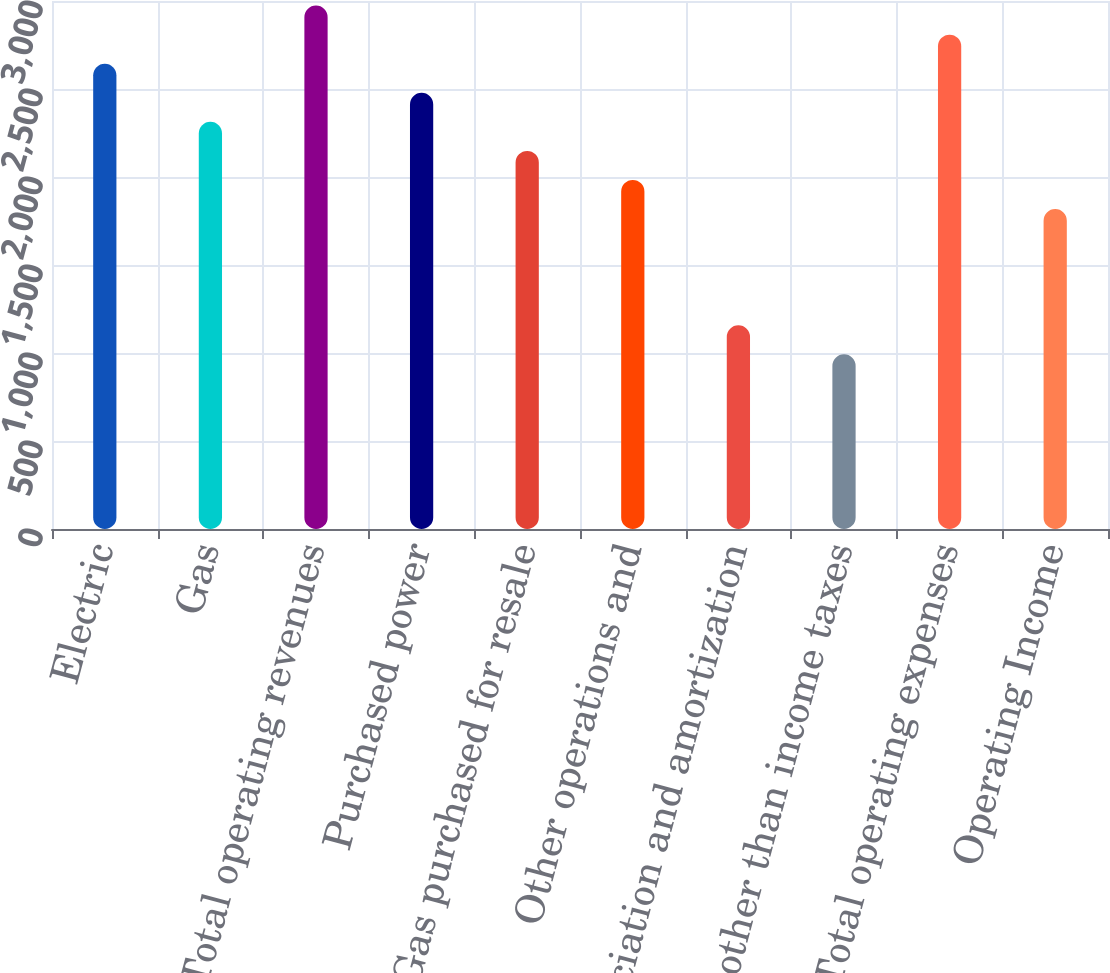Convert chart to OTSL. <chart><loc_0><loc_0><loc_500><loc_500><bar_chart><fcel>Electric<fcel>Gas<fcel>Total operating revenues<fcel>Purchased power<fcel>Gas purchased for resale<fcel>Other operations and<fcel>Depreciation and amortization<fcel>Taxes other than income taxes<fcel>Total operating expenses<fcel>Operating Income<nl><fcel>2643.6<fcel>2313.4<fcel>2973.8<fcel>2478.5<fcel>2148.3<fcel>1983.2<fcel>1157.7<fcel>992.6<fcel>2808.7<fcel>1818.1<nl></chart> 